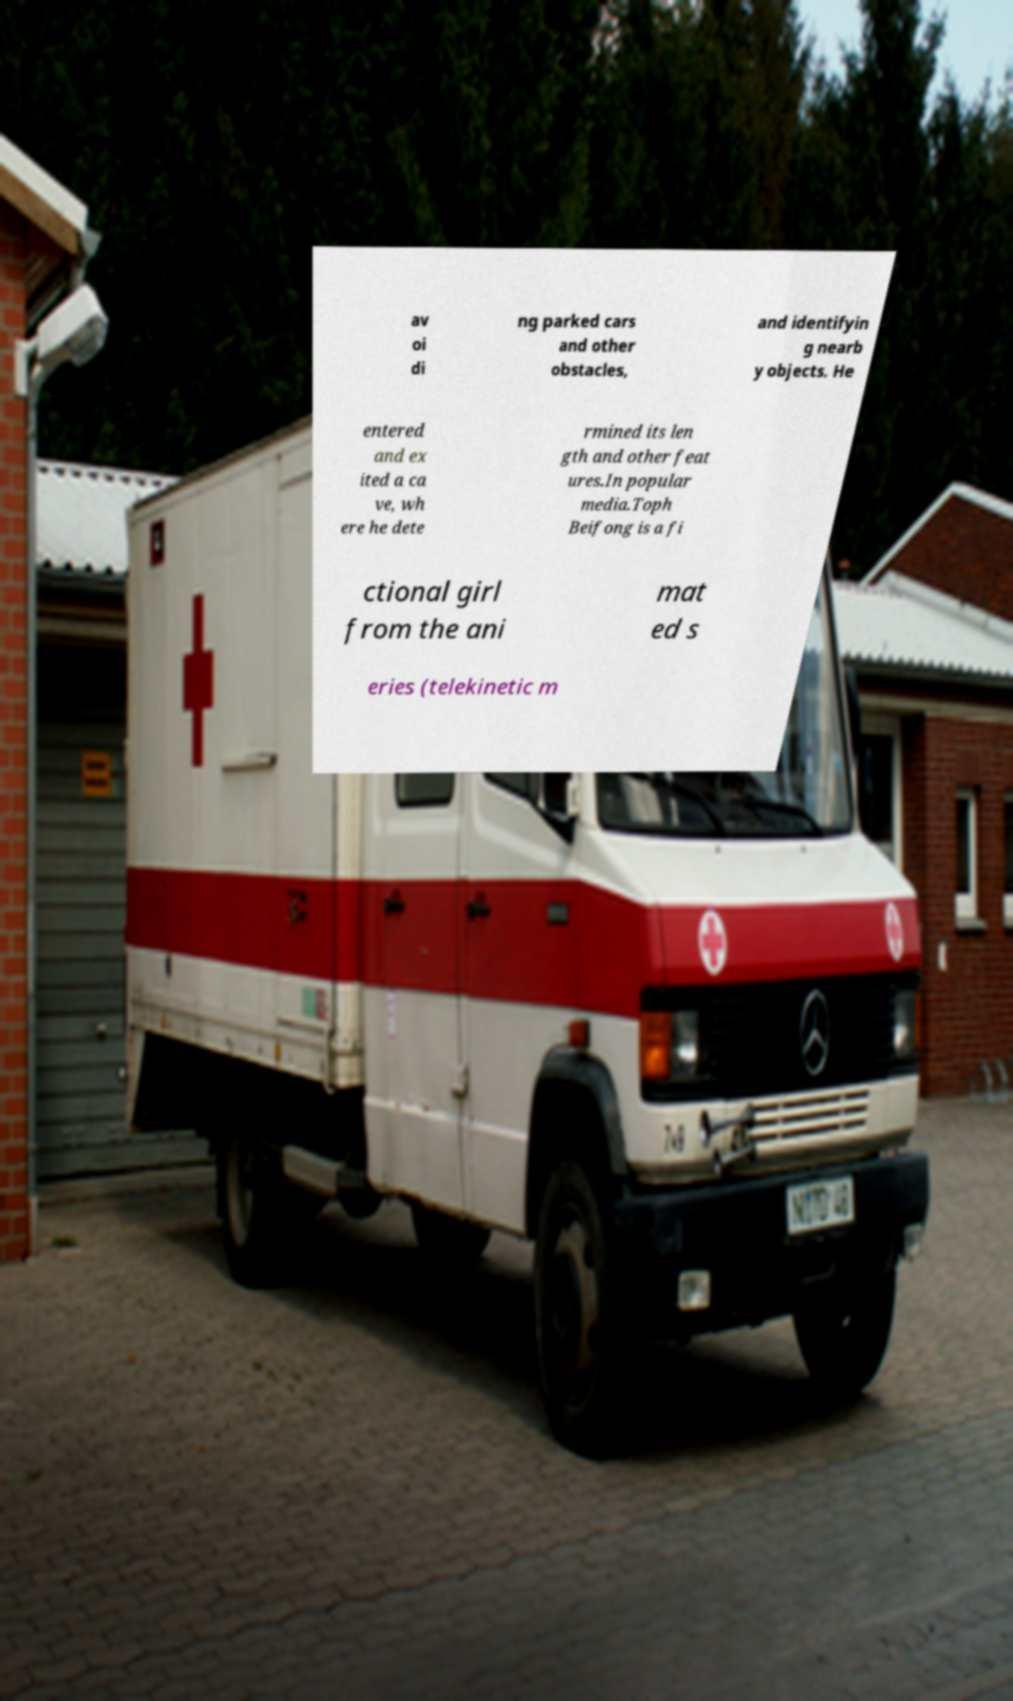There's text embedded in this image that I need extracted. Can you transcribe it verbatim? av oi di ng parked cars and other obstacles, and identifyin g nearb y objects. He entered and ex ited a ca ve, wh ere he dete rmined its len gth and other feat ures.In popular media.Toph Beifong is a fi ctional girl from the ani mat ed s eries (telekinetic m 